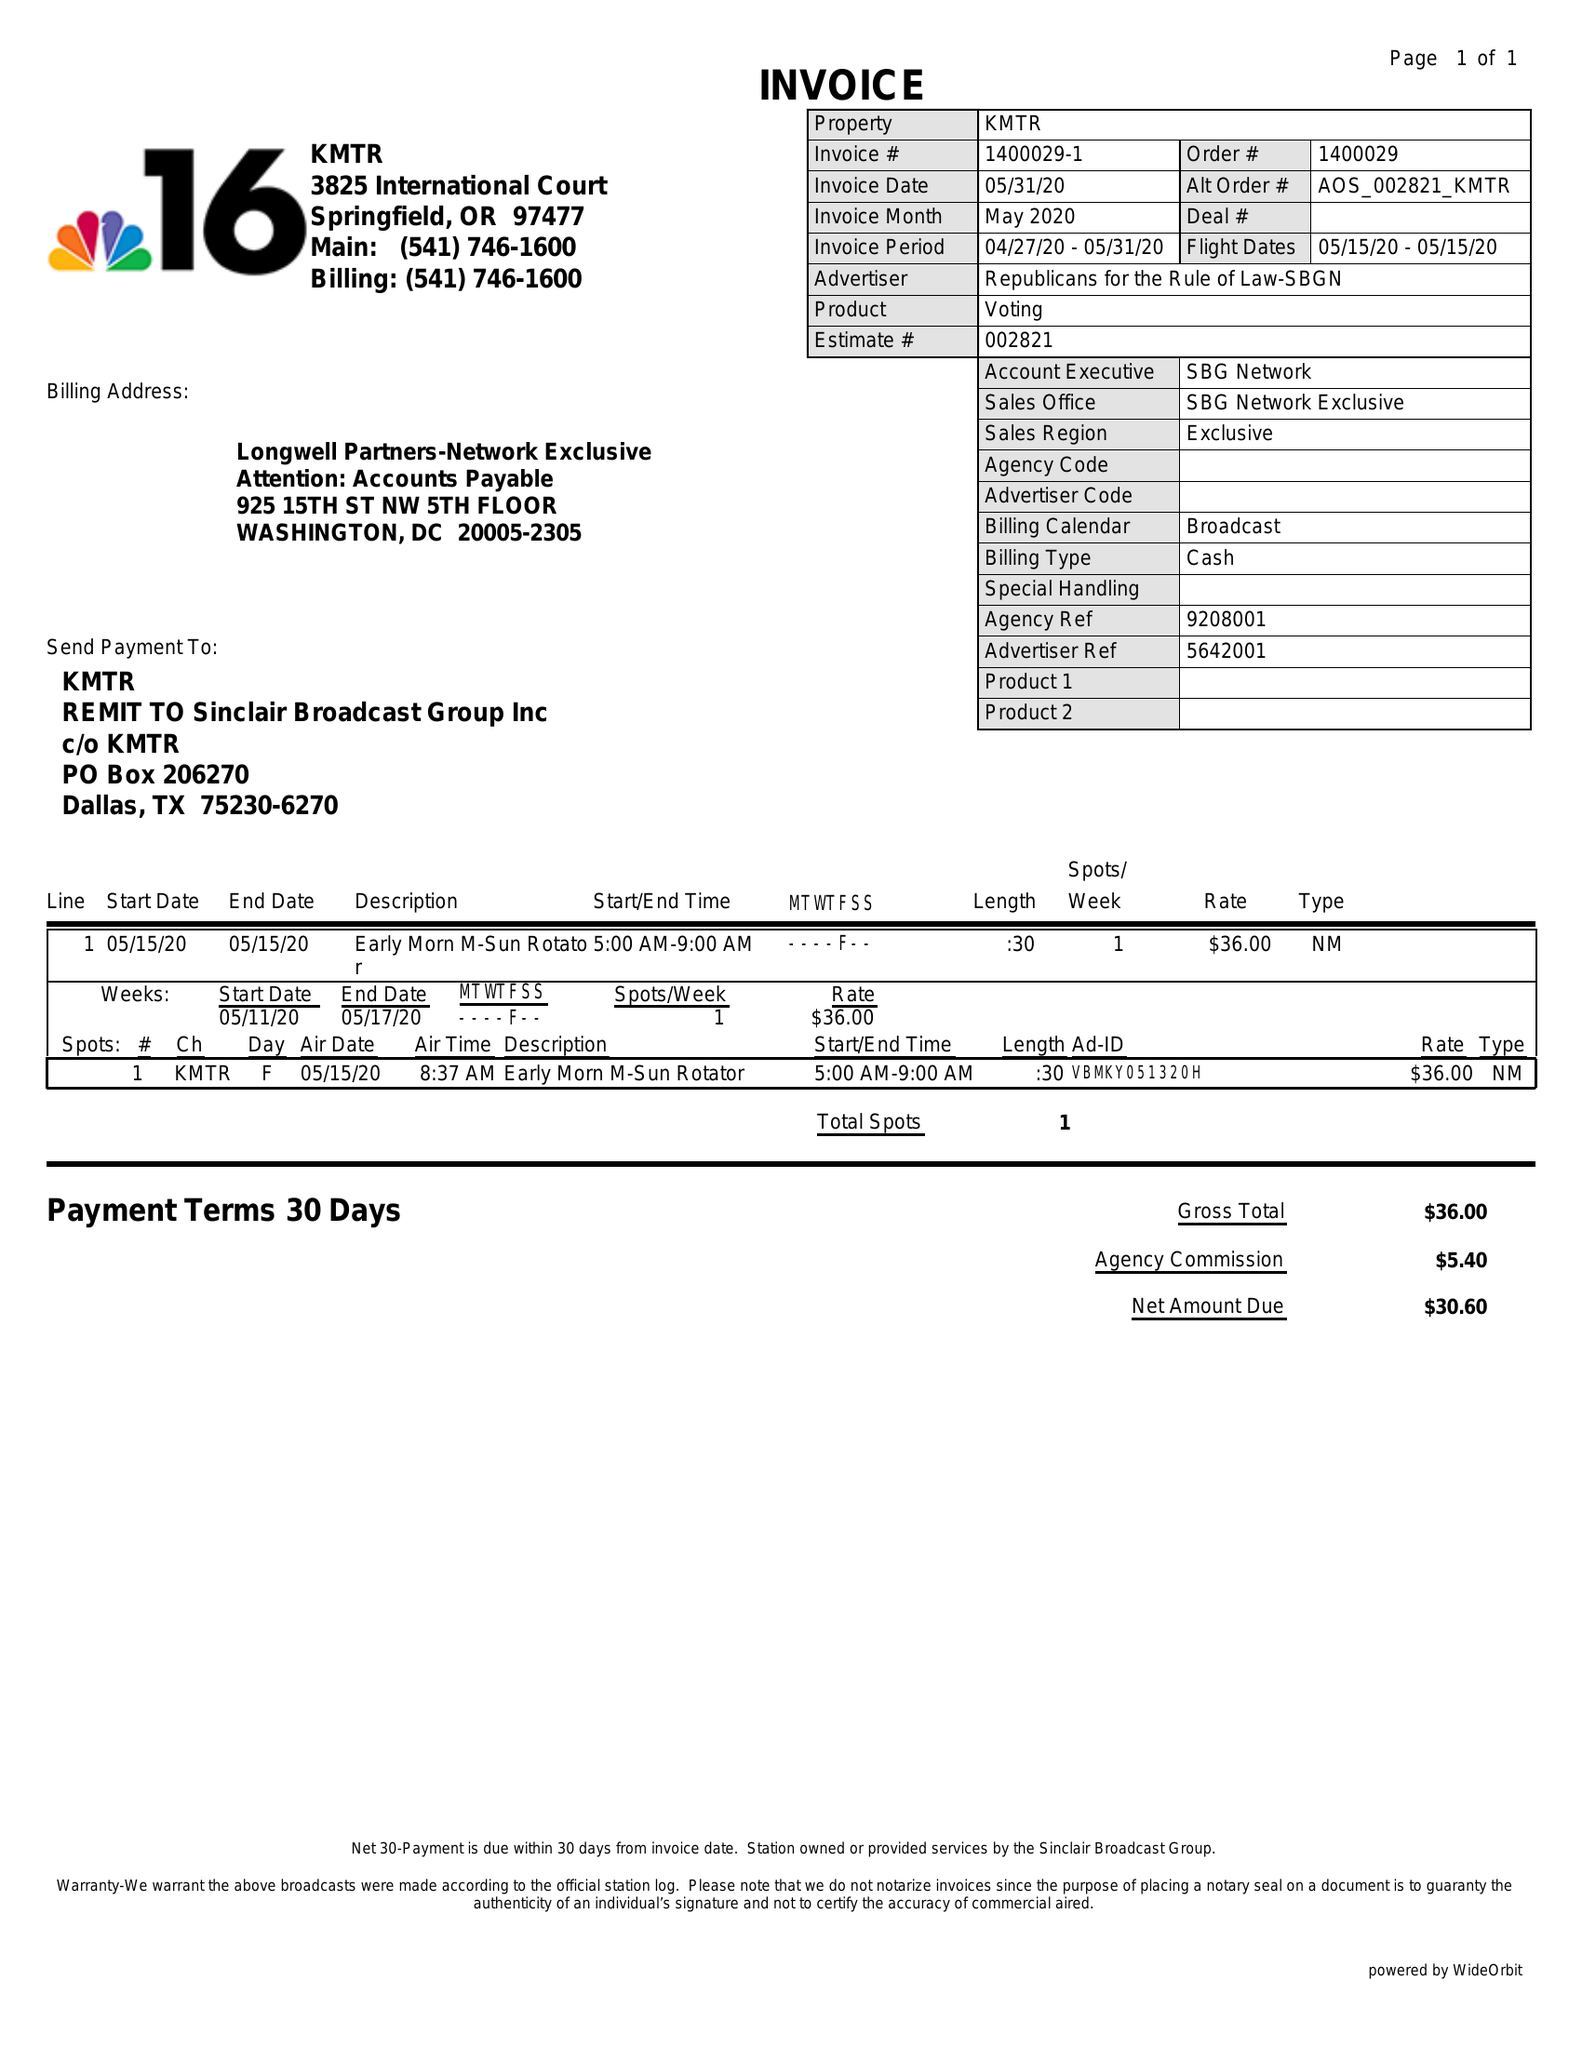What is the value for the flight_from?
Answer the question using a single word or phrase. 05/15/20 